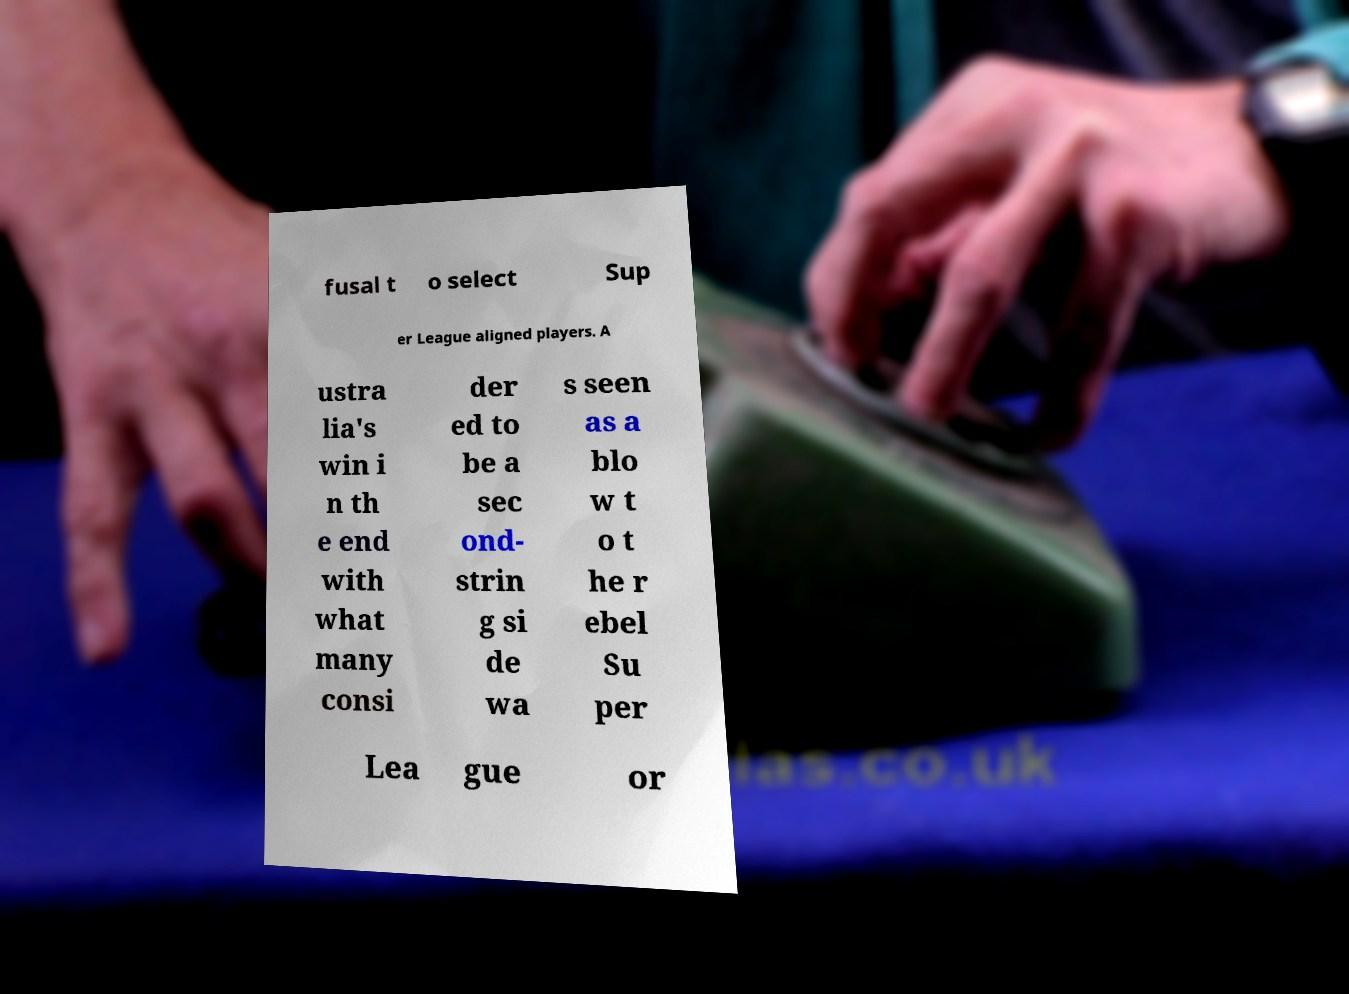For documentation purposes, I need the text within this image transcribed. Could you provide that? fusal t o select Sup er League aligned players. A ustra lia's win i n th e end with what many consi der ed to be a sec ond- strin g si de wa s seen as a blo w t o t he r ebel Su per Lea gue or 